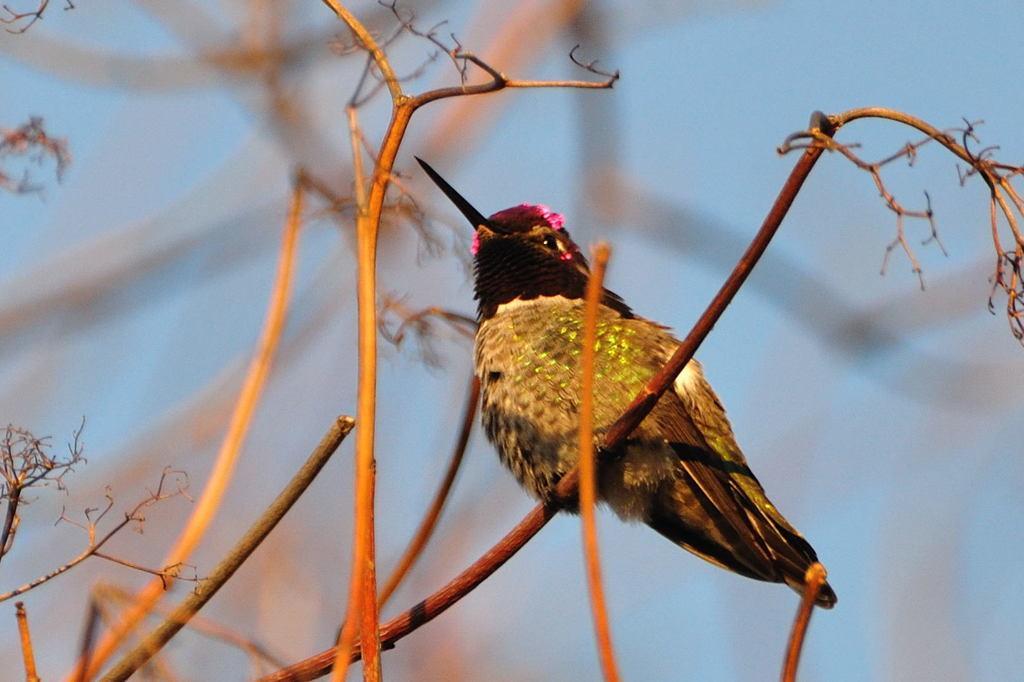Could you give a brief overview of what you see in this image? In the center of the image we can see branches. On the branch, we can see one bird, which is in multi color. In the background we can see the sky. 